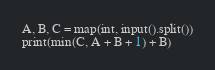<code> <loc_0><loc_0><loc_500><loc_500><_Python_>A, B, C = map(int, input().split())
print(min(C, A + B + 1) + B)
</code> 